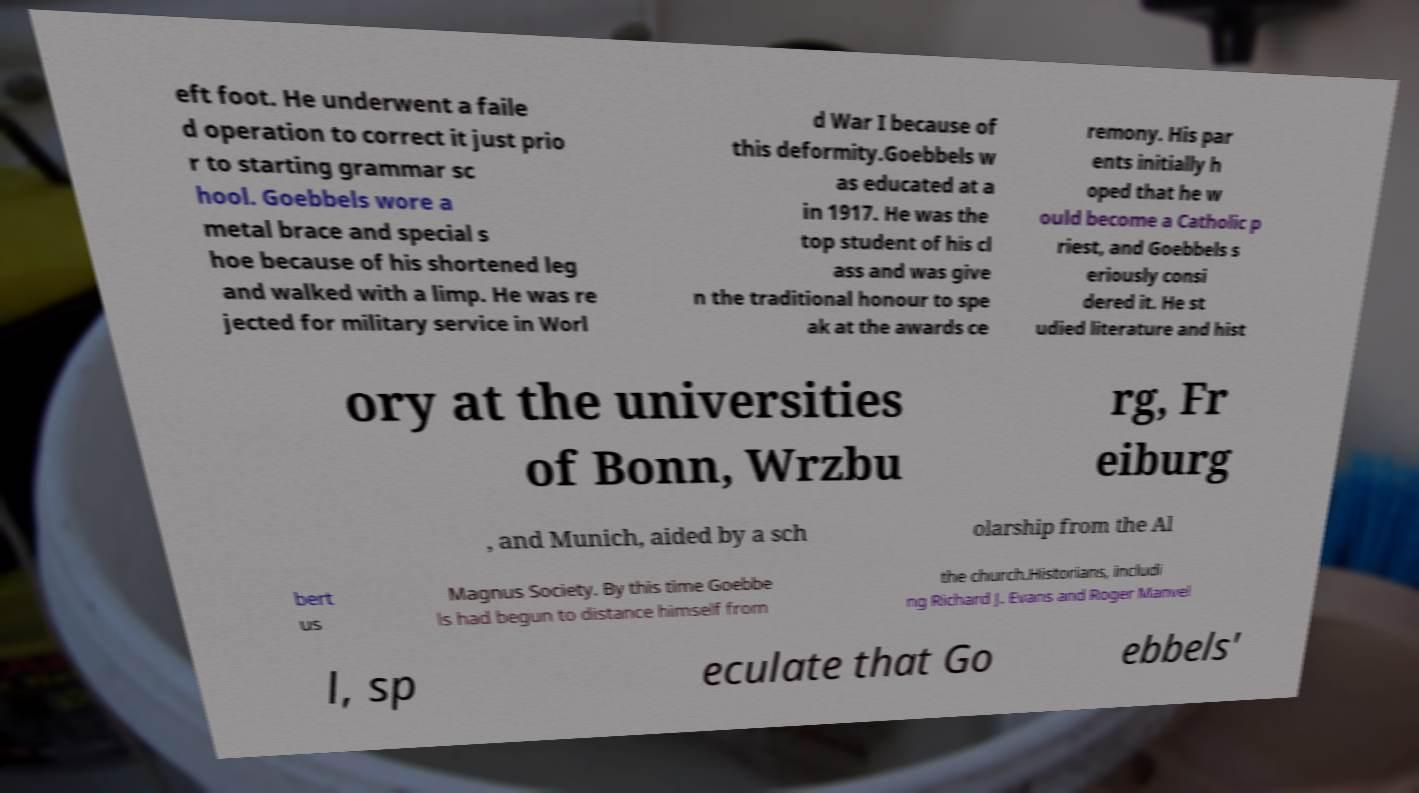Can you accurately transcribe the text from the provided image for me? eft foot. He underwent a faile d operation to correct it just prio r to starting grammar sc hool. Goebbels wore a metal brace and special s hoe because of his shortened leg and walked with a limp. He was re jected for military service in Worl d War I because of this deformity.Goebbels w as educated at a in 1917. He was the top student of his cl ass and was give n the traditional honour to spe ak at the awards ce remony. His par ents initially h oped that he w ould become a Catholic p riest, and Goebbels s eriously consi dered it. He st udied literature and hist ory at the universities of Bonn, Wrzbu rg, Fr eiburg , and Munich, aided by a sch olarship from the Al bert us Magnus Society. By this time Goebbe ls had begun to distance himself from the church.Historians, includi ng Richard J. Evans and Roger Manvel l, sp eculate that Go ebbels' 